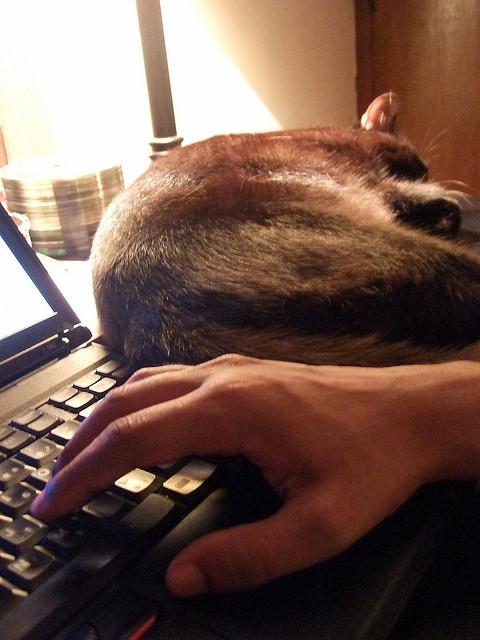Describe the objects in this image and their specific colors. I can see cat in white, black, maroon, and brown tones, laptop in white, black, ivory, and gray tones, and people in white, maroon, black, tan, and brown tones in this image. 